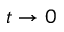Convert formula to latex. <formula><loc_0><loc_0><loc_500><loc_500>t \to 0</formula> 